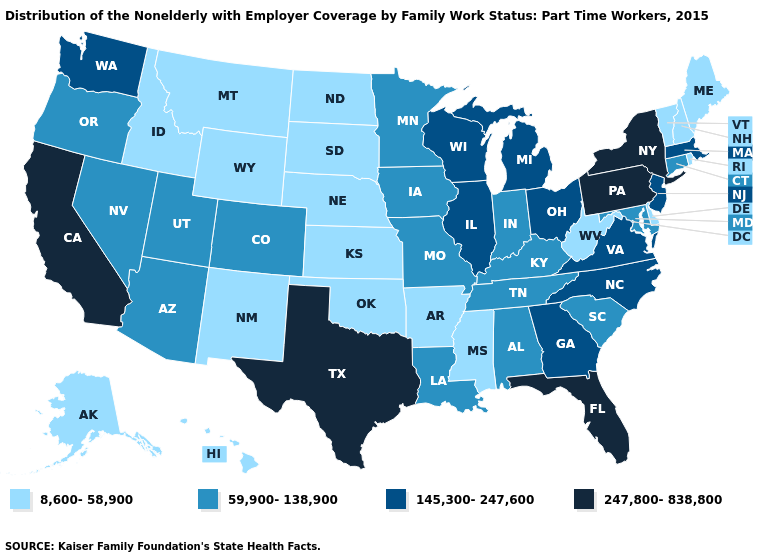Name the states that have a value in the range 59,900-138,900?
Keep it brief. Alabama, Arizona, Colorado, Connecticut, Indiana, Iowa, Kentucky, Louisiana, Maryland, Minnesota, Missouri, Nevada, Oregon, South Carolina, Tennessee, Utah. What is the value of Arkansas?
Concise answer only. 8,600-58,900. Which states hav the highest value in the South?
Concise answer only. Florida, Texas. Does Indiana have the same value as Kentucky?
Keep it brief. Yes. What is the value of Texas?
Short answer required. 247,800-838,800. What is the value of Wyoming?
Keep it brief. 8,600-58,900. Does Arizona have the highest value in the USA?
Write a very short answer. No. Which states hav the highest value in the MidWest?
Be succinct. Illinois, Michigan, Ohio, Wisconsin. Is the legend a continuous bar?
Keep it brief. No. Does Michigan have the highest value in the USA?
Quick response, please. No. What is the value of Florida?
Keep it brief. 247,800-838,800. Name the states that have a value in the range 8,600-58,900?
Be succinct. Alaska, Arkansas, Delaware, Hawaii, Idaho, Kansas, Maine, Mississippi, Montana, Nebraska, New Hampshire, New Mexico, North Dakota, Oklahoma, Rhode Island, South Dakota, Vermont, West Virginia, Wyoming. What is the value of New York?
Concise answer only. 247,800-838,800. Which states have the lowest value in the MidWest?
Give a very brief answer. Kansas, Nebraska, North Dakota, South Dakota. How many symbols are there in the legend?
Be succinct. 4. 